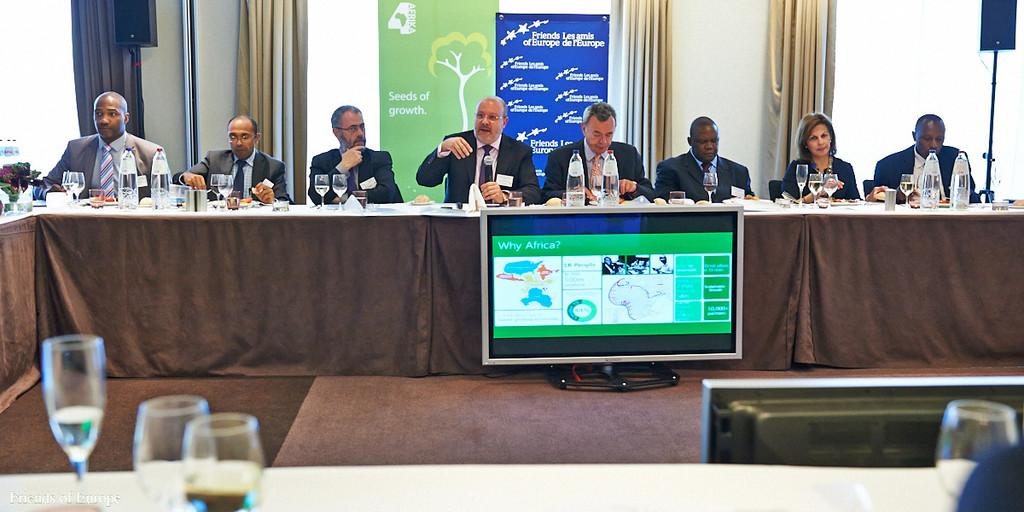<image>
Describe the image concisely. A conference table with a banner behind advertising Friends Les arnis of Europe de rEurope. 